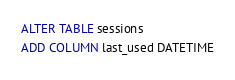Convert code to text. <code><loc_0><loc_0><loc_500><loc_500><_SQL_>ALTER TABLE sessions
ADD COLUMN last_used DATETIME
</code> 